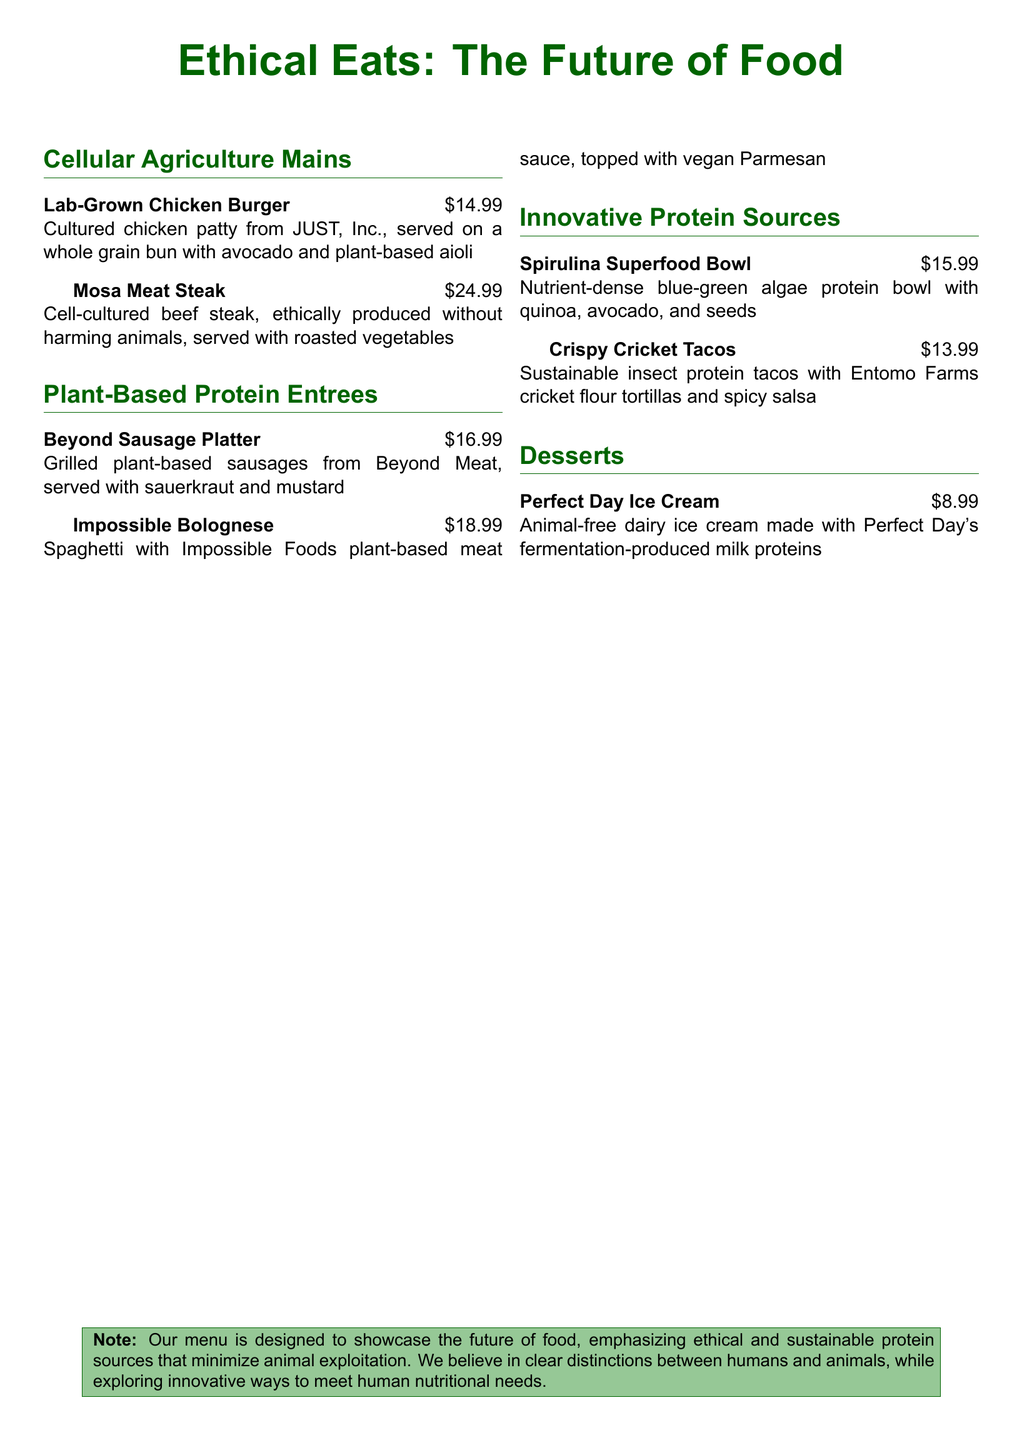What is the price of the Lab-Grown Chicken Burger? The price of the Lab-Grown Chicken Burger is listed next to the item on the menu.
Answer: $14.99 What type of protein is used in the Mosa Meat Steak? The Mosa Meat Steak mentions the type of protein used, highlighting that it's cell-cultured beef.
Answer: Cell-cultured beef How much does the Spirulina Superfood Bowl cost? The cost of the Spirulina Superfood Bowl can be found listed on the menu alongside the dish name.
Answer: $15.99 Which company produces the lab-grown chicken patty? The document states the company producing the chicken patty in the menu description.
Answer: JUST, Inc What is the main focus of the menu according to the note? The note at the bottom of the menu outlines the main intention behind the offerings.
Answer: Ethical and sustainable protein sources How is the Perfect Day Ice Cream described? The description of Perfect Day Ice Cream is provided in the menu's dessert section.
Answer: Animal-free dairy ice cream What distinguishes the plant-based protein options from traditional proteins? The menu indicates the specific attributes of the dishes that set them apart from traditional proteins.
Answer: Minimize animal exploitation How many tacos are included in the Crispy Cricket Tacos dish? The document does not specify the number of tacos in this dish, indicating a possible ambiguity.
Answer: Not specified 